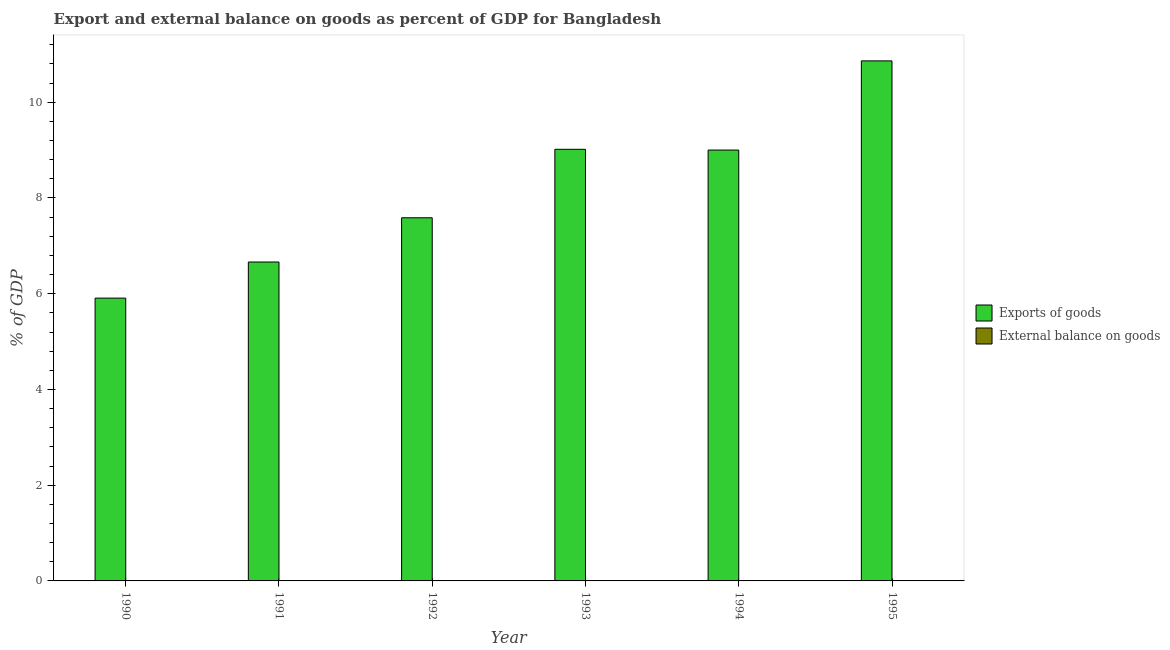Are the number of bars on each tick of the X-axis equal?
Provide a succinct answer. Yes. How many bars are there on the 5th tick from the left?
Ensure brevity in your answer.  1. How many bars are there on the 4th tick from the right?
Your answer should be very brief. 1. What is the label of the 6th group of bars from the left?
Offer a very short reply. 1995. Across all years, what is the maximum export of goods as percentage of gdp?
Your answer should be very brief. 10.86. What is the total export of goods as percentage of gdp in the graph?
Your answer should be compact. 49.04. What is the difference between the export of goods as percentage of gdp in 1991 and that in 1992?
Provide a succinct answer. -0.92. What is the difference between the export of goods as percentage of gdp in 1994 and the external balance on goods as percentage of gdp in 1993?
Provide a succinct answer. -0.02. In the year 1993, what is the difference between the export of goods as percentage of gdp and external balance on goods as percentage of gdp?
Provide a short and direct response. 0. In how many years, is the external balance on goods as percentage of gdp greater than 10.8 %?
Keep it short and to the point. 0. What is the ratio of the export of goods as percentage of gdp in 1990 to that in 1994?
Keep it short and to the point. 0.66. Is the export of goods as percentage of gdp in 1993 less than that in 1995?
Your answer should be very brief. Yes. Is the difference between the export of goods as percentage of gdp in 1990 and 1993 greater than the difference between the external balance on goods as percentage of gdp in 1990 and 1993?
Give a very brief answer. No. What is the difference between the highest and the second highest export of goods as percentage of gdp?
Ensure brevity in your answer.  1.85. What is the difference between the highest and the lowest export of goods as percentage of gdp?
Your answer should be very brief. 4.96. In how many years, is the external balance on goods as percentage of gdp greater than the average external balance on goods as percentage of gdp taken over all years?
Provide a succinct answer. 0. Is the sum of the export of goods as percentage of gdp in 1990 and 1994 greater than the maximum external balance on goods as percentage of gdp across all years?
Make the answer very short. Yes. How many years are there in the graph?
Keep it short and to the point. 6. Does the graph contain any zero values?
Your answer should be compact. Yes. How many legend labels are there?
Your answer should be compact. 2. What is the title of the graph?
Your answer should be very brief. Export and external balance on goods as percent of GDP for Bangladesh. Does "Domestic Liabilities" appear as one of the legend labels in the graph?
Provide a succinct answer. No. What is the label or title of the Y-axis?
Give a very brief answer. % of GDP. What is the % of GDP in Exports of goods in 1990?
Your answer should be very brief. 5.91. What is the % of GDP in Exports of goods in 1991?
Offer a very short reply. 6.66. What is the % of GDP of External balance on goods in 1991?
Offer a very short reply. 0. What is the % of GDP of Exports of goods in 1992?
Your answer should be very brief. 7.59. What is the % of GDP of Exports of goods in 1993?
Provide a short and direct response. 9.02. What is the % of GDP in External balance on goods in 1993?
Your answer should be very brief. 0. What is the % of GDP of Exports of goods in 1994?
Give a very brief answer. 9. What is the % of GDP of Exports of goods in 1995?
Your response must be concise. 10.86. What is the % of GDP in External balance on goods in 1995?
Your answer should be compact. 0. Across all years, what is the maximum % of GDP of Exports of goods?
Offer a very short reply. 10.86. Across all years, what is the minimum % of GDP of Exports of goods?
Offer a very short reply. 5.91. What is the total % of GDP in Exports of goods in the graph?
Provide a short and direct response. 49.04. What is the total % of GDP of External balance on goods in the graph?
Provide a short and direct response. 0. What is the difference between the % of GDP in Exports of goods in 1990 and that in 1991?
Give a very brief answer. -0.75. What is the difference between the % of GDP in Exports of goods in 1990 and that in 1992?
Provide a short and direct response. -1.68. What is the difference between the % of GDP in Exports of goods in 1990 and that in 1993?
Make the answer very short. -3.11. What is the difference between the % of GDP of Exports of goods in 1990 and that in 1994?
Offer a very short reply. -3.09. What is the difference between the % of GDP in Exports of goods in 1990 and that in 1995?
Provide a succinct answer. -4.96. What is the difference between the % of GDP in Exports of goods in 1991 and that in 1992?
Your response must be concise. -0.92. What is the difference between the % of GDP in Exports of goods in 1991 and that in 1993?
Provide a short and direct response. -2.35. What is the difference between the % of GDP in Exports of goods in 1991 and that in 1994?
Give a very brief answer. -2.34. What is the difference between the % of GDP of Exports of goods in 1991 and that in 1995?
Give a very brief answer. -4.2. What is the difference between the % of GDP of Exports of goods in 1992 and that in 1993?
Give a very brief answer. -1.43. What is the difference between the % of GDP of Exports of goods in 1992 and that in 1994?
Give a very brief answer. -1.41. What is the difference between the % of GDP in Exports of goods in 1992 and that in 1995?
Provide a succinct answer. -3.28. What is the difference between the % of GDP of Exports of goods in 1993 and that in 1994?
Your response must be concise. 0.02. What is the difference between the % of GDP of Exports of goods in 1993 and that in 1995?
Keep it short and to the point. -1.85. What is the difference between the % of GDP in Exports of goods in 1994 and that in 1995?
Keep it short and to the point. -1.86. What is the average % of GDP of Exports of goods per year?
Offer a very short reply. 8.17. What is the ratio of the % of GDP of Exports of goods in 1990 to that in 1991?
Your response must be concise. 0.89. What is the ratio of the % of GDP in Exports of goods in 1990 to that in 1992?
Ensure brevity in your answer.  0.78. What is the ratio of the % of GDP in Exports of goods in 1990 to that in 1993?
Your response must be concise. 0.66. What is the ratio of the % of GDP in Exports of goods in 1990 to that in 1994?
Keep it short and to the point. 0.66. What is the ratio of the % of GDP of Exports of goods in 1990 to that in 1995?
Provide a short and direct response. 0.54. What is the ratio of the % of GDP in Exports of goods in 1991 to that in 1992?
Your answer should be very brief. 0.88. What is the ratio of the % of GDP of Exports of goods in 1991 to that in 1993?
Keep it short and to the point. 0.74. What is the ratio of the % of GDP of Exports of goods in 1991 to that in 1994?
Provide a succinct answer. 0.74. What is the ratio of the % of GDP of Exports of goods in 1991 to that in 1995?
Your response must be concise. 0.61. What is the ratio of the % of GDP in Exports of goods in 1992 to that in 1993?
Give a very brief answer. 0.84. What is the ratio of the % of GDP in Exports of goods in 1992 to that in 1994?
Offer a very short reply. 0.84. What is the ratio of the % of GDP in Exports of goods in 1992 to that in 1995?
Ensure brevity in your answer.  0.7. What is the ratio of the % of GDP of Exports of goods in 1993 to that in 1995?
Offer a terse response. 0.83. What is the ratio of the % of GDP of Exports of goods in 1994 to that in 1995?
Your answer should be compact. 0.83. What is the difference between the highest and the second highest % of GDP in Exports of goods?
Your answer should be very brief. 1.85. What is the difference between the highest and the lowest % of GDP of Exports of goods?
Offer a very short reply. 4.96. 